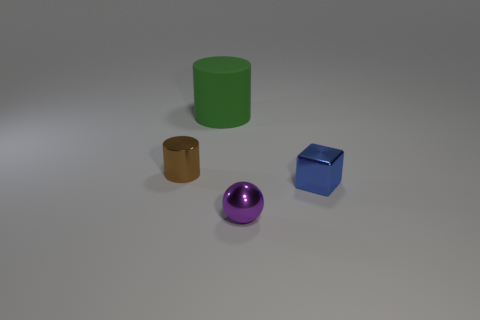Add 4 cyan metal objects. How many objects exist? 8 Subtract all spheres. How many objects are left? 3 Subtract all big gray metal balls. Subtract all green matte objects. How many objects are left? 3 Add 2 blue things. How many blue things are left? 3 Add 2 tiny purple blocks. How many tiny purple blocks exist? 2 Subtract 0 red cylinders. How many objects are left? 4 